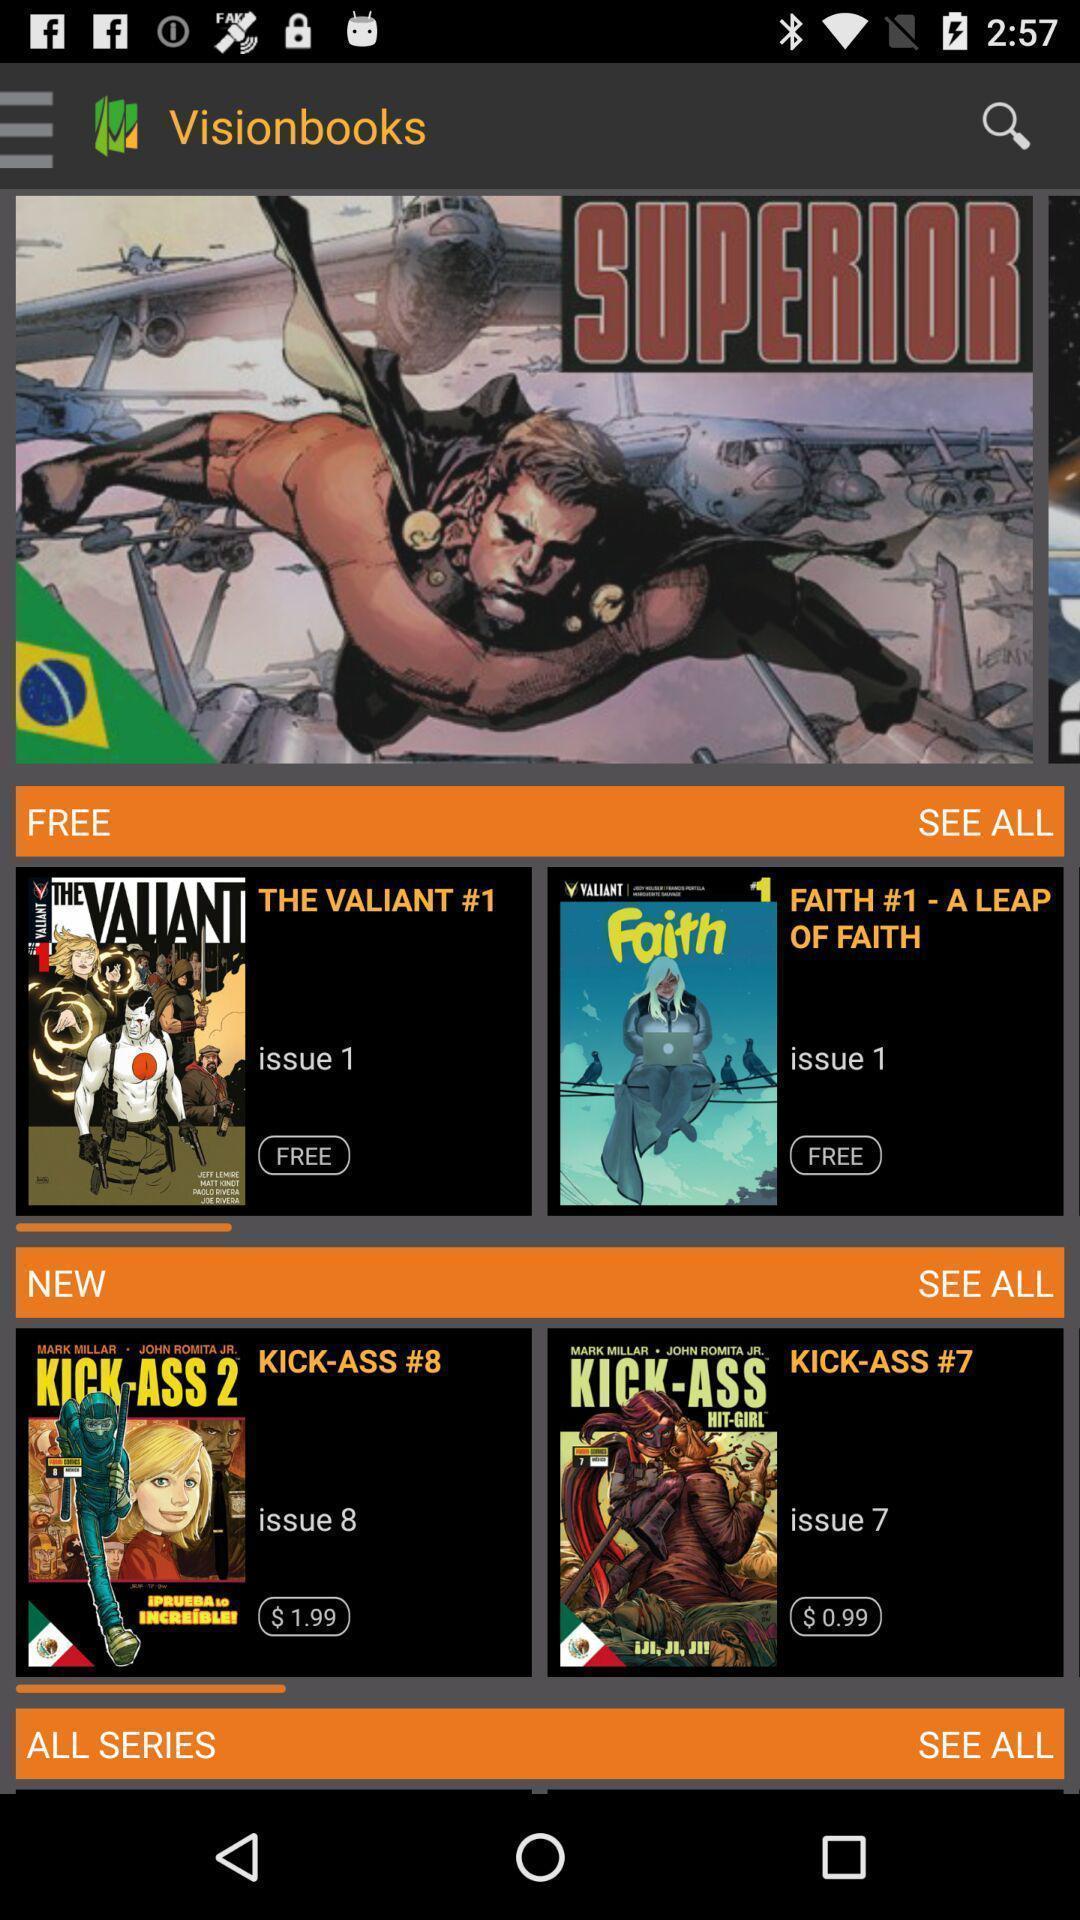What can you discern from this picture? Videos of a superior in vision books. 